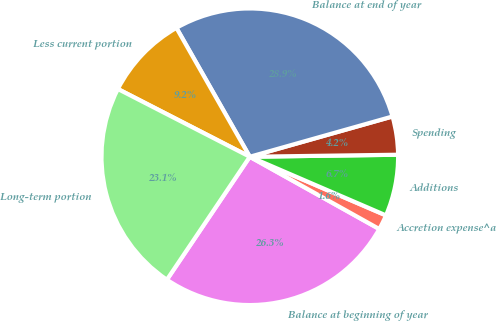Convert chart. <chart><loc_0><loc_0><loc_500><loc_500><pie_chart><fcel>Balance at beginning of year<fcel>Accretion expense^a<fcel>Additions<fcel>Spending<fcel>Balance at end of year<fcel>Less current portion<fcel>Long-term portion<nl><fcel>26.34%<fcel>1.63%<fcel>6.69%<fcel>4.16%<fcel>28.86%<fcel>9.21%<fcel>23.11%<nl></chart> 